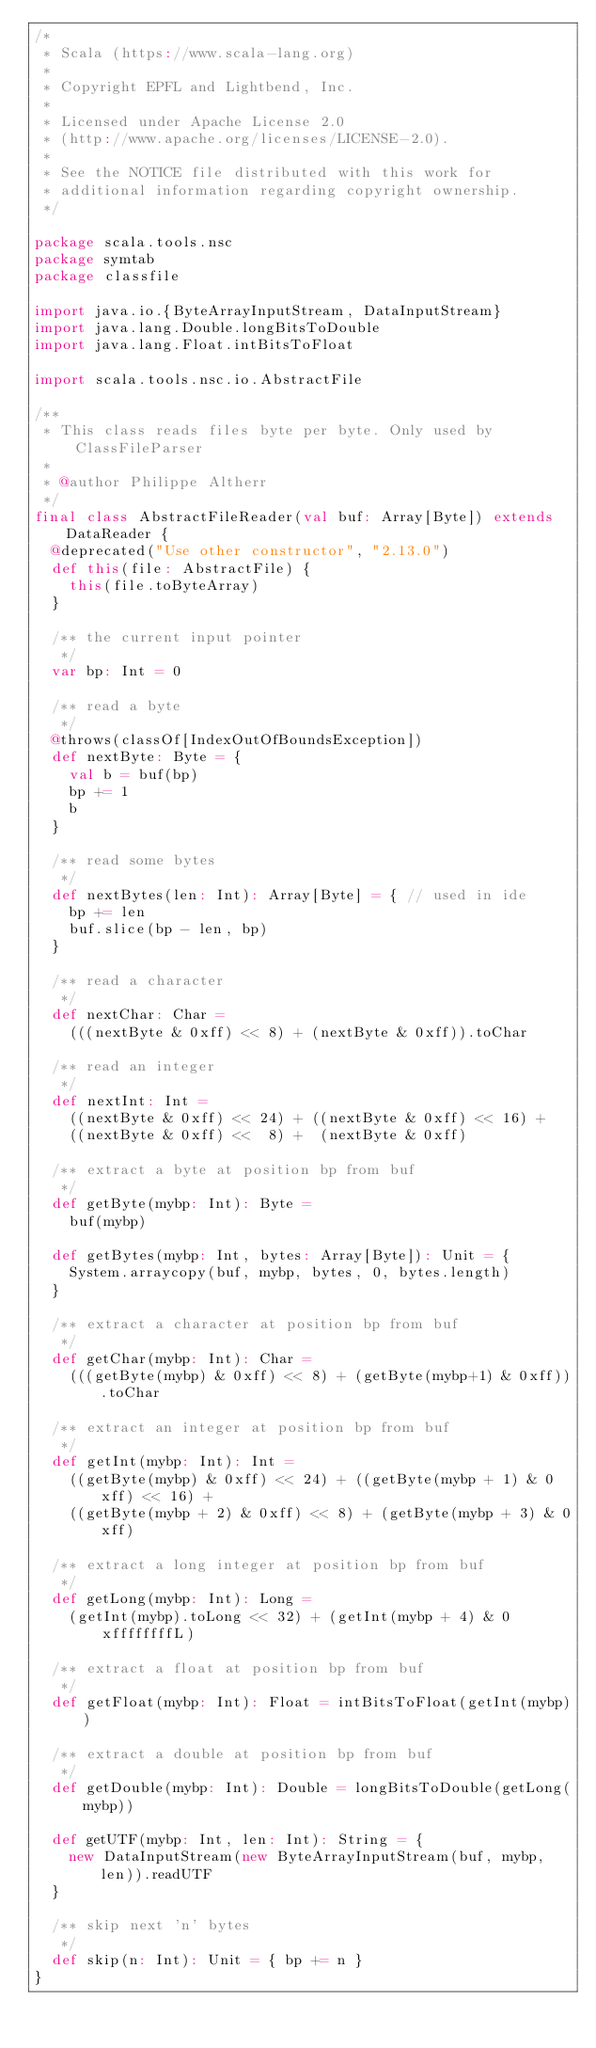<code> <loc_0><loc_0><loc_500><loc_500><_Scala_>/*
 * Scala (https://www.scala-lang.org)
 *
 * Copyright EPFL and Lightbend, Inc.
 *
 * Licensed under Apache License 2.0
 * (http://www.apache.org/licenses/LICENSE-2.0).
 *
 * See the NOTICE file distributed with this work for
 * additional information regarding copyright ownership.
 */

package scala.tools.nsc
package symtab
package classfile

import java.io.{ByteArrayInputStream, DataInputStream}
import java.lang.Double.longBitsToDouble
import java.lang.Float.intBitsToFloat

import scala.tools.nsc.io.AbstractFile

/**
 * This class reads files byte per byte. Only used by ClassFileParser
 *
 * @author Philippe Altherr
 */
final class AbstractFileReader(val buf: Array[Byte]) extends DataReader {
  @deprecated("Use other constructor", "2.13.0")
  def this(file: AbstractFile) {
    this(file.toByteArray)
  }

  /** the current input pointer
   */
  var bp: Int = 0

  /** read a byte
   */
  @throws(classOf[IndexOutOfBoundsException])
  def nextByte: Byte = {
    val b = buf(bp)
    bp += 1
    b
  }

  /** read some bytes
   */
  def nextBytes(len: Int): Array[Byte] = { // used in ide
    bp += len
    buf.slice(bp - len, bp)
  }

  /** read a character
   */
  def nextChar: Char =
    (((nextByte & 0xff) << 8) + (nextByte & 0xff)).toChar

  /** read an integer
   */
  def nextInt: Int =
    ((nextByte & 0xff) << 24) + ((nextByte & 0xff) << 16) +
    ((nextByte & 0xff) <<  8) +  (nextByte & 0xff)

  /** extract a byte at position bp from buf
   */
  def getByte(mybp: Int): Byte =
    buf(mybp)

  def getBytes(mybp: Int, bytes: Array[Byte]): Unit = {
    System.arraycopy(buf, mybp, bytes, 0, bytes.length)
  }

  /** extract a character at position bp from buf
   */
  def getChar(mybp: Int): Char =
    (((getByte(mybp) & 0xff) << 8) + (getByte(mybp+1) & 0xff)).toChar

  /** extract an integer at position bp from buf
   */
  def getInt(mybp: Int): Int =
    ((getByte(mybp) & 0xff) << 24) + ((getByte(mybp + 1) & 0xff) << 16) +
    ((getByte(mybp + 2) & 0xff) << 8) + (getByte(mybp + 3) & 0xff)

  /** extract a long integer at position bp from buf
   */
  def getLong(mybp: Int): Long =
    (getInt(mybp).toLong << 32) + (getInt(mybp + 4) & 0xffffffffL)

  /** extract a float at position bp from buf
   */
  def getFloat(mybp: Int): Float = intBitsToFloat(getInt(mybp))

  /** extract a double at position bp from buf
   */
  def getDouble(mybp: Int): Double = longBitsToDouble(getLong(mybp))

  def getUTF(mybp: Int, len: Int): String = {
    new DataInputStream(new ByteArrayInputStream(buf, mybp, len)).readUTF
  }

  /** skip next 'n' bytes
   */
  def skip(n: Int): Unit = { bp += n }
}
</code> 